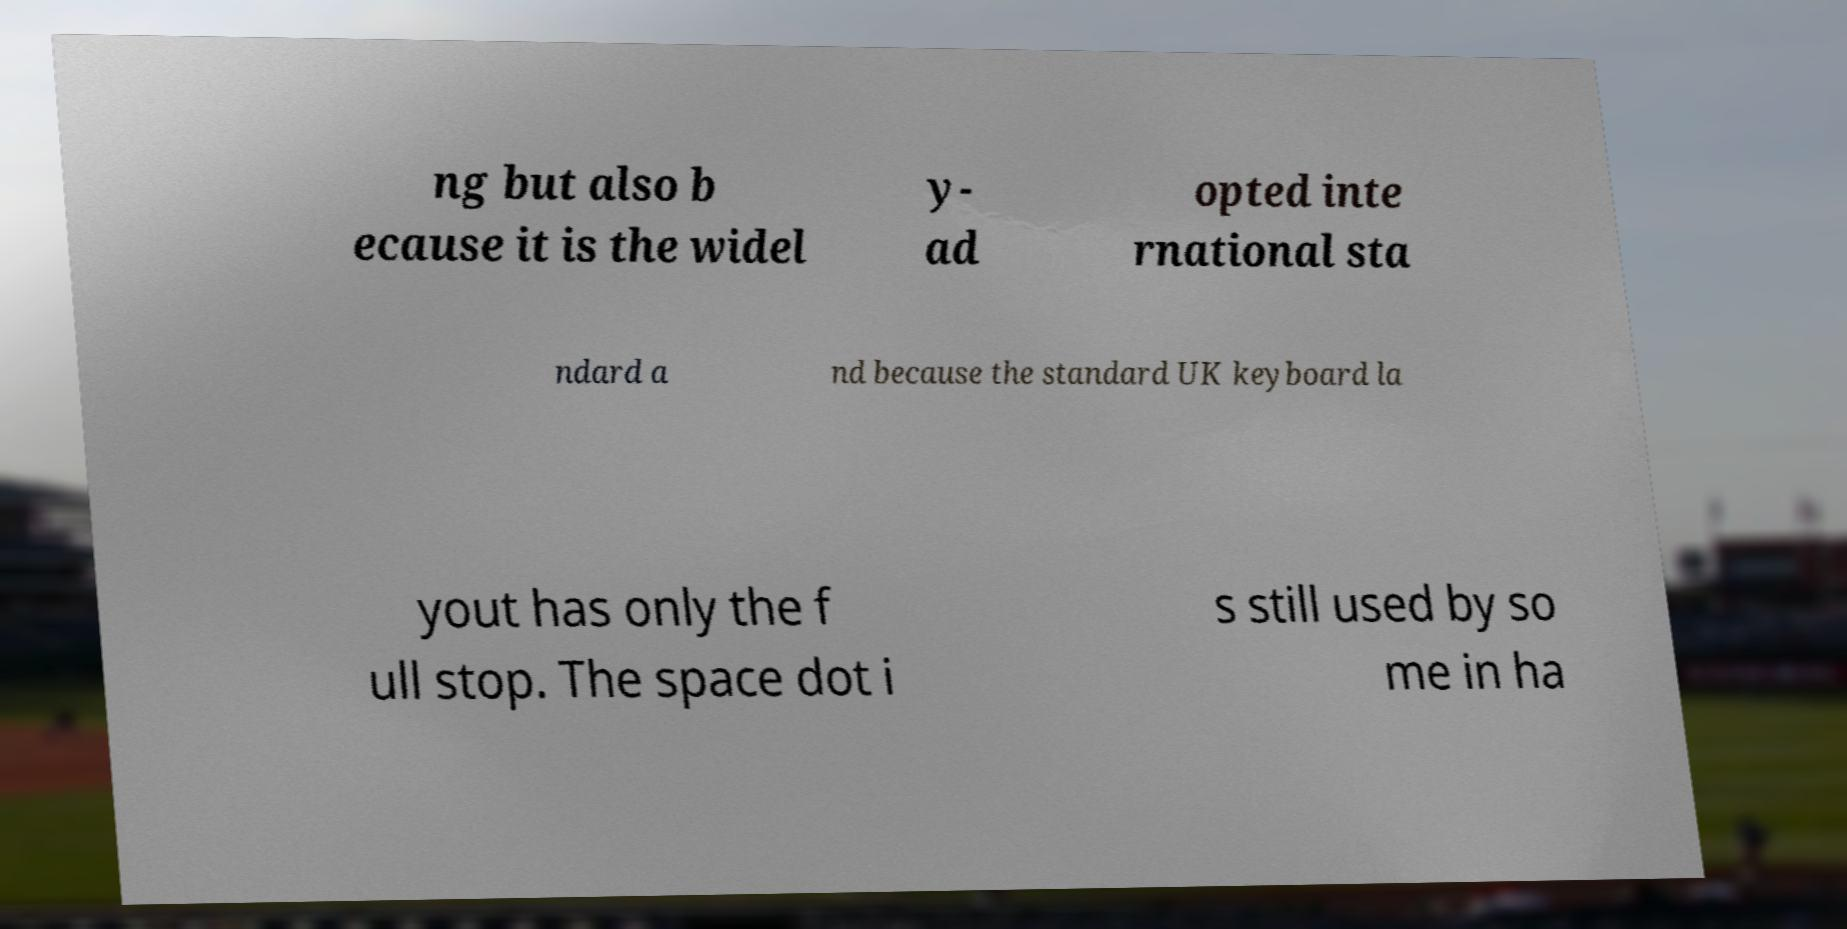Could you assist in decoding the text presented in this image and type it out clearly? ng but also b ecause it is the widel y- ad opted inte rnational sta ndard a nd because the standard UK keyboard la yout has only the f ull stop. The space dot i s still used by so me in ha 